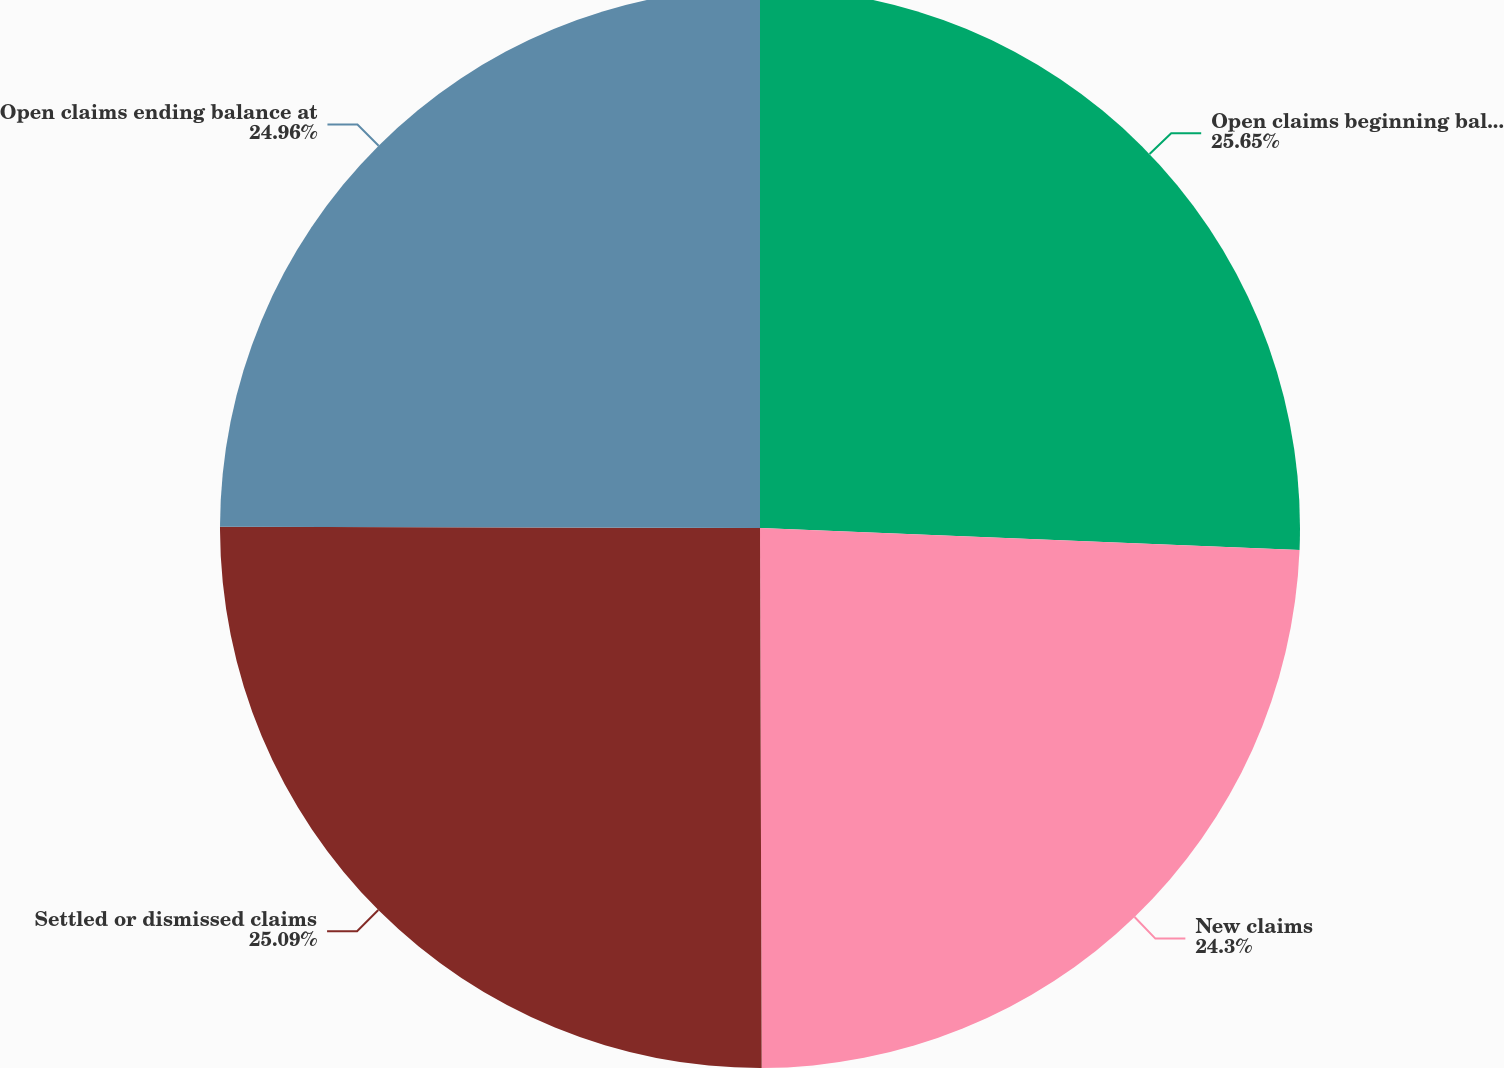<chart> <loc_0><loc_0><loc_500><loc_500><pie_chart><fcel>Open claims beginning balance<fcel>New claims<fcel>Settled or dismissed claims<fcel>Open claims ending balance at<nl><fcel>25.65%<fcel>24.3%<fcel>25.09%<fcel>24.96%<nl></chart> 